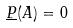<formula> <loc_0><loc_0><loc_500><loc_500>\underline { P } ( A ) = 0</formula> 